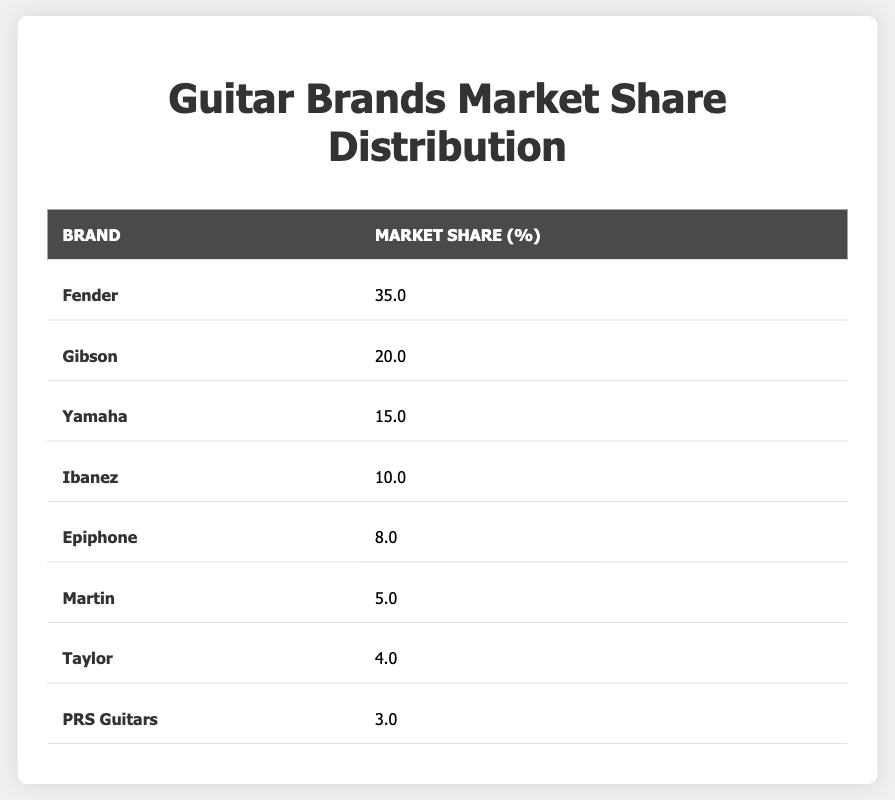What is the market share percentage of Fender? Directly referencing the table, Fender's market share percentage is clearly listed as 35.0%.
Answer: 35.0 Which brand has the lowest market share? By examining the market share percentages in the table, PRS Guitars has the smallest percentage at 3.0%.
Answer: PRS Guitars What is the total market share of the top three guitar brands? The top three brands by market share are Fender (35.0%), Gibson (20.0%), and Yamaha (15.0). Their total market share can be calculated as 35.0 + 20.0 + 15.0 = 70.0%.
Answer: 70.0 Is the market share of Martin greater than 4%? Looking at the table, Martin has a market share of 5.0%. Since 5.0% is greater than 4%, the statement is true.
Answer: Yes What is the difference in market share between Gibson and Ibanez? Gibson has a market share of 20.0%, while Ibanez has 10.0%. The difference can be calculated as 20.0 - 10.0 = 10.0%.
Answer: 10.0 What percentage of the total market share do the brands Epiphone and Taylor account for collectively? Epiphone has 8.0% and Taylor has 4.0%. The total market share for these two brands is 8.0 + 4.0 = 12.0%.
Answer: 12.0 Which brand has a market share percentage of 5% or lower? The brands with a market share of 5% or lower listed in the table are Martin (5.0%), Taylor (4.0%), and PRS Guitars (3.0%). Thus, all three meet the criteria.
Answer: Martin, Taylor, PRS Guitars If you were to rank the brands by their market share, what would be the second brand? According to the table, after Fender, which has the highest market share of 35.0%, Gibson with 20.0% would be rated as the second brand.
Answer: Gibson What is the average market share percentage of all seven brands excluding Fender? The market shares to consider are Gibson (20.0%), Yamaha (15.0%), Ibanez (10.0%), Epiphone (8.0%), Martin (5.0%), Taylor (4.0%), and PRS Guitars (3.0%). Adding these values gives 20.0 + 15.0 + 10.0 + 8.0 + 5.0 + 4.0 + 3.0 = 55.0%. There are six brands, so the average is 55.0 / 6 = 9.17%.
Answer: 9.17 